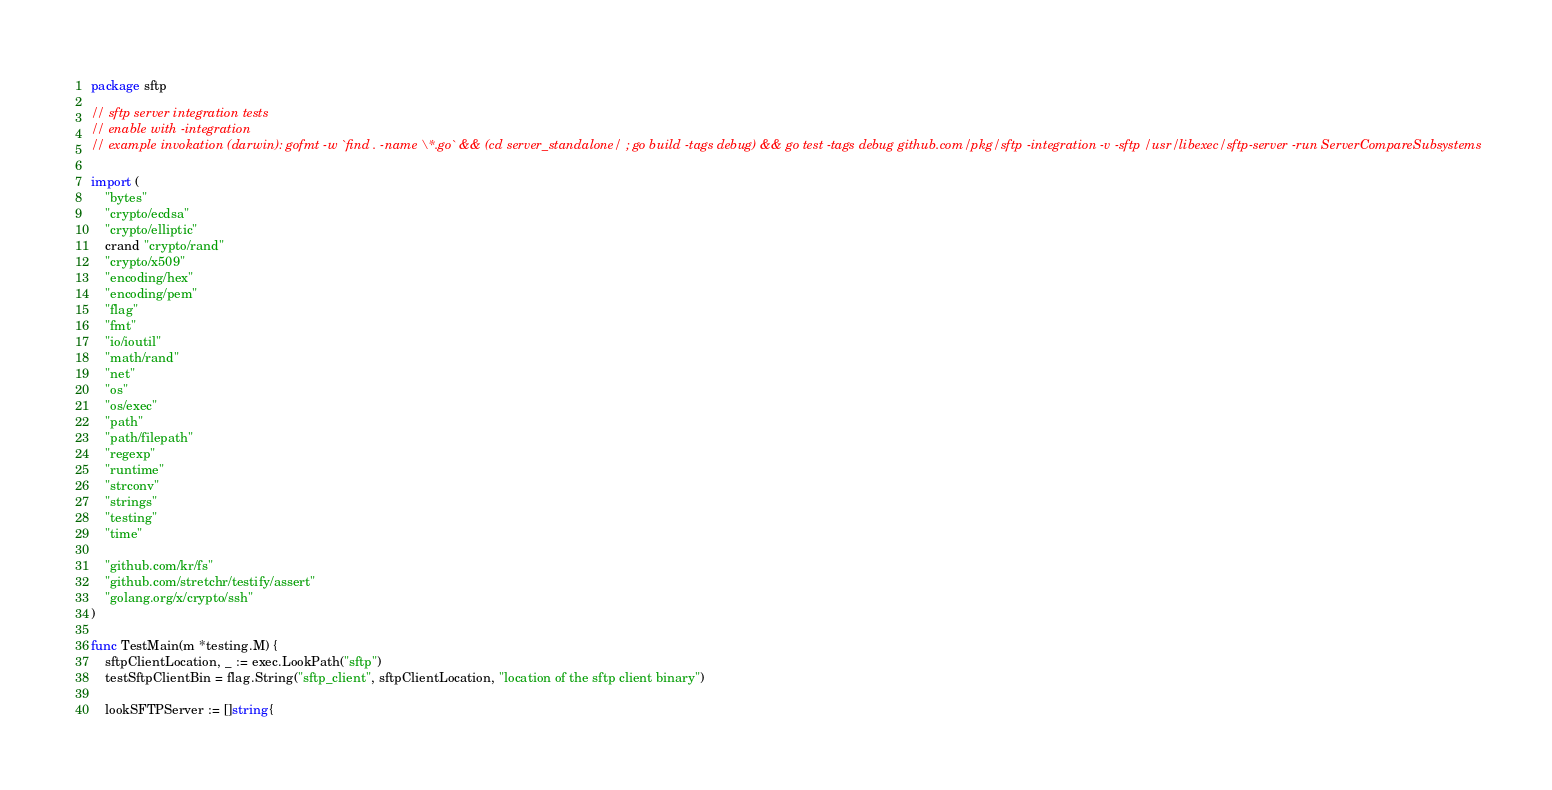<code> <loc_0><loc_0><loc_500><loc_500><_Go_>package sftp

// sftp server integration tests
// enable with -integration
// example invokation (darwin): gofmt -w `find . -name \*.go` && (cd server_standalone/ ; go build -tags debug) && go test -tags debug github.com/pkg/sftp -integration -v -sftp /usr/libexec/sftp-server -run ServerCompareSubsystems

import (
	"bytes"
	"crypto/ecdsa"
	"crypto/elliptic"
	crand "crypto/rand"
	"crypto/x509"
	"encoding/hex"
	"encoding/pem"
	"flag"
	"fmt"
	"io/ioutil"
	"math/rand"
	"net"
	"os"
	"os/exec"
	"path"
	"path/filepath"
	"regexp"
	"runtime"
	"strconv"
	"strings"
	"testing"
	"time"

	"github.com/kr/fs"
	"github.com/stretchr/testify/assert"
	"golang.org/x/crypto/ssh"
)

func TestMain(m *testing.M) {
	sftpClientLocation, _ := exec.LookPath("sftp")
	testSftpClientBin = flag.String("sftp_client", sftpClientLocation, "location of the sftp client binary")

	lookSFTPServer := []string{</code> 